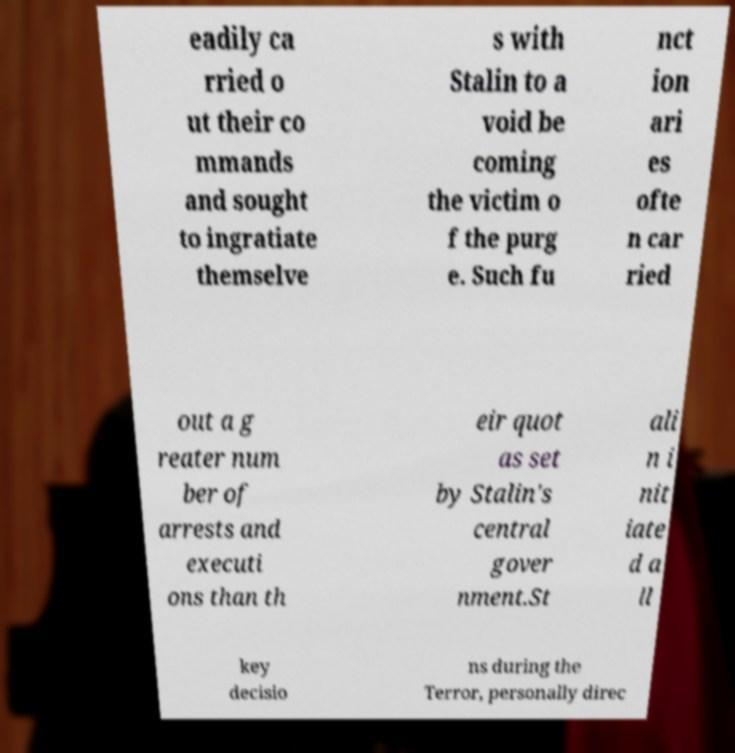I need the written content from this picture converted into text. Can you do that? eadily ca rried o ut their co mmands and sought to ingratiate themselve s with Stalin to a void be coming the victim o f the purg e. Such fu nct ion ari es ofte n car ried out a g reater num ber of arrests and executi ons than th eir quot as set by Stalin's central gover nment.St ali n i nit iate d a ll key decisio ns during the Terror, personally direc 